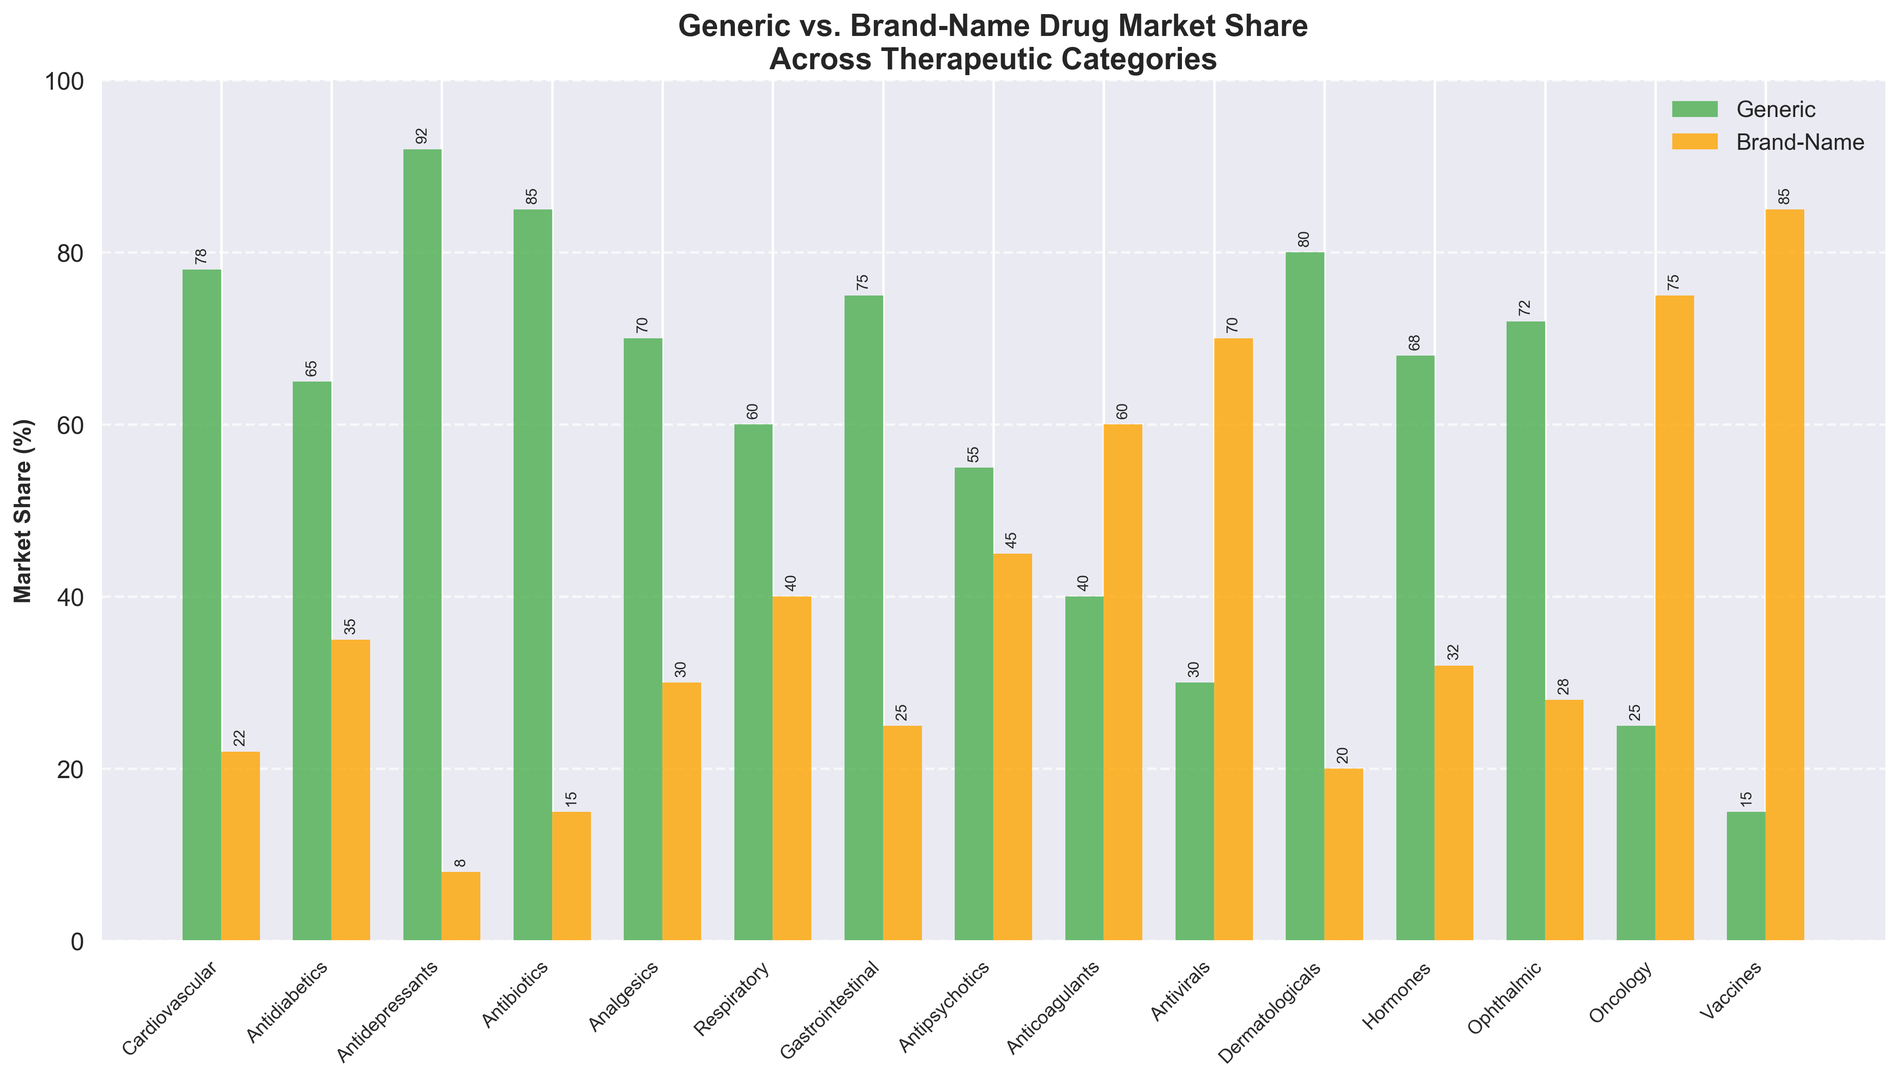What's the therapeutic category with the highest market share for brand-name drugs? The tallest blue bar in the figure represents the highest market share for brand-name drugs. By looking at the figure, the 'Vaccines' category has the highest brand-name market share at 85%.
Answer: Vaccines Which therapeutic category has the lowest market share for generic drugs? The shortest green bar in the figure indicates the lowest market share for generic drugs. The 'Vaccines' category has the lowest generic market share at 15%.
Answer: Vaccines In how many categories does the market share for generic drugs exceed 50%? Count the number of green bars that are taller than the halfway mark on the y-axis. There are 11 categories where the market share for generic drugs exceeds 50% (Cardiovascular, Antidiabetics, Antidepressants, Antibiotics, Analgesics, Gastrointestinal, Dermatologicals, Hormones, Ophthalmic, Respiratory, Antipsychotics).
Answer: 11 What is the difference in market share between generic and brand-name drugs in the 'Cardiovascular' category? Find the 'Cardiovascular' category on the x-axis and then subtract the market share of brand-name drugs from the market share of generic drugs (78% - 22% = 56%).
Answer: 56% Which therapeutic categories have a higher market share for brand-name drugs than generic drugs? Identify the categories where the orange bar is taller than the green bar. The categories are 'Antivirals', 'Oncology', and 'Vaccines'.
Answer: Antivirals, Oncology, Vaccines What's the average market share for brand-name drugs across all therapeutic categories? Sum the market share percentages for brand-name drugs and then divide by the number of categories: (22 + 35 + 8 + 15 + 30 + 40 + 25 + 45 + 60 + 70 + 20 + 32 + 28 + 75 + 85) / 15 = 40%.
Answer: 40% How much shorter is the brand-name bar for 'Antidepressants' compared to the generic bar in the same category? Find the 'Antidepressants' category and subtract the height of the brand-name bar from the height of the generic bar (92% - 8% = 84%).
Answer: 84% What is the combined market share for generic drugs in the 'Cardiovascular' and 'Analgesics' categories? Add the market share percentages for generic drugs in 'Cardiovascular' and 'Analgesics' (78% + 70% = 148%).
Answer: 148% Which category has almost equal market share between generic and brand-name drugs? Look for green and orange bars that are almost the same height. 'Antipsychotics' has a closer market share between generic (55%) and brand-name (45%) drugs.
Answer: Antipsychotics What is the total market share for brand-name drugs in the 'Antivirals' and 'Oncology' categories? Add the market share percentages for brand-name drugs in 'Antivirals' and 'Oncology' (70% + 75% = 145%).
Answer: 145% 